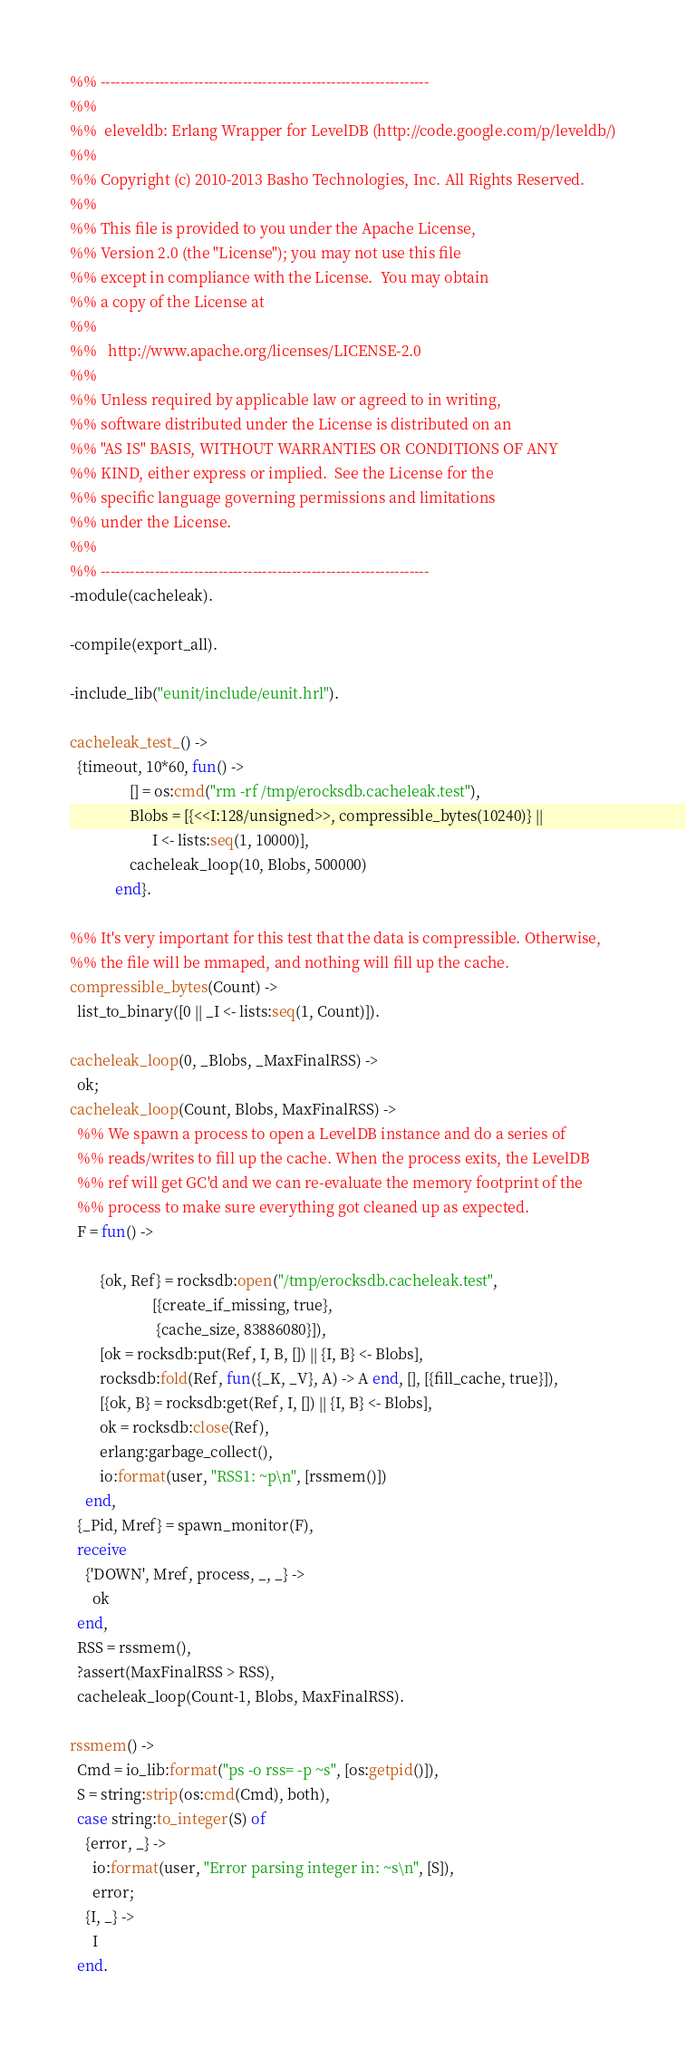Convert code to text. <code><loc_0><loc_0><loc_500><loc_500><_Erlang_>%% -------------------------------------------------------------------
%%
%%  eleveldb: Erlang Wrapper for LevelDB (http://code.google.com/p/leveldb/)
%%
%% Copyright (c) 2010-2013 Basho Technologies, Inc. All Rights Reserved.
%%
%% This file is provided to you under the Apache License,
%% Version 2.0 (the "License"); you may not use this file
%% except in compliance with the License.  You may obtain
%% a copy of the License at
%%
%%   http://www.apache.org/licenses/LICENSE-2.0
%%
%% Unless required by applicable law or agreed to in writing,
%% software distributed under the License is distributed on an
%% "AS IS" BASIS, WITHOUT WARRANTIES OR CONDITIONS OF ANY
%% KIND, either express or implied.  See the License for the
%% specific language governing permissions and limitations
%% under the License.
%%
%% -------------------------------------------------------------------
-module(cacheleak).

-compile(export_all).

-include_lib("eunit/include/eunit.hrl").

cacheleak_test_() ->
  {timeout, 10*60, fun() ->
                [] = os:cmd("rm -rf /tmp/erocksdb.cacheleak.test"),
                Blobs = [{<<I:128/unsigned>>, compressible_bytes(10240)} ||
                      I <- lists:seq(1, 10000)],
                cacheleak_loop(10, Blobs, 500000)
            end}.

%% It's very important for this test that the data is compressible. Otherwise,
%% the file will be mmaped, and nothing will fill up the cache.
compressible_bytes(Count) ->
  list_to_binary([0 || _I <- lists:seq(1, Count)]).

cacheleak_loop(0, _Blobs, _MaxFinalRSS) ->
  ok;
cacheleak_loop(Count, Blobs, MaxFinalRSS) ->
  %% We spawn a process to open a LevelDB instance and do a series of
  %% reads/writes to fill up the cache. When the process exits, the LevelDB
  %% ref will get GC'd and we can re-evaluate the memory footprint of the
  %% process to make sure everything got cleaned up as expected.
  F = fun() ->

        {ok, Ref} = rocksdb:open("/tmp/erocksdb.cacheleak.test",
                      [{create_if_missing, true},
                       {cache_size, 83886080}]),
        [ok = rocksdb:put(Ref, I, B, []) || {I, B} <- Blobs],
        rocksdb:fold(Ref, fun({_K, _V}, A) -> A end, [], [{fill_cache, true}]),
        [{ok, B} = rocksdb:get(Ref, I, []) || {I, B} <- Blobs],
        ok = rocksdb:close(Ref),
        erlang:garbage_collect(),
        io:format(user, "RSS1: ~p\n", [rssmem()])
    end,
  {_Pid, Mref} = spawn_monitor(F),
  receive
    {'DOWN', Mref, process, _, _} ->
      ok
  end,
  RSS = rssmem(),
  ?assert(MaxFinalRSS > RSS),
  cacheleak_loop(Count-1, Blobs, MaxFinalRSS).

rssmem() ->
  Cmd = io_lib:format("ps -o rss= -p ~s", [os:getpid()]),
  S = string:strip(os:cmd(Cmd), both),
  case string:to_integer(S) of
    {error, _} ->
      io:format(user, "Error parsing integer in: ~s\n", [S]),
      error;
    {I, _} ->
      I
  end.
</code> 